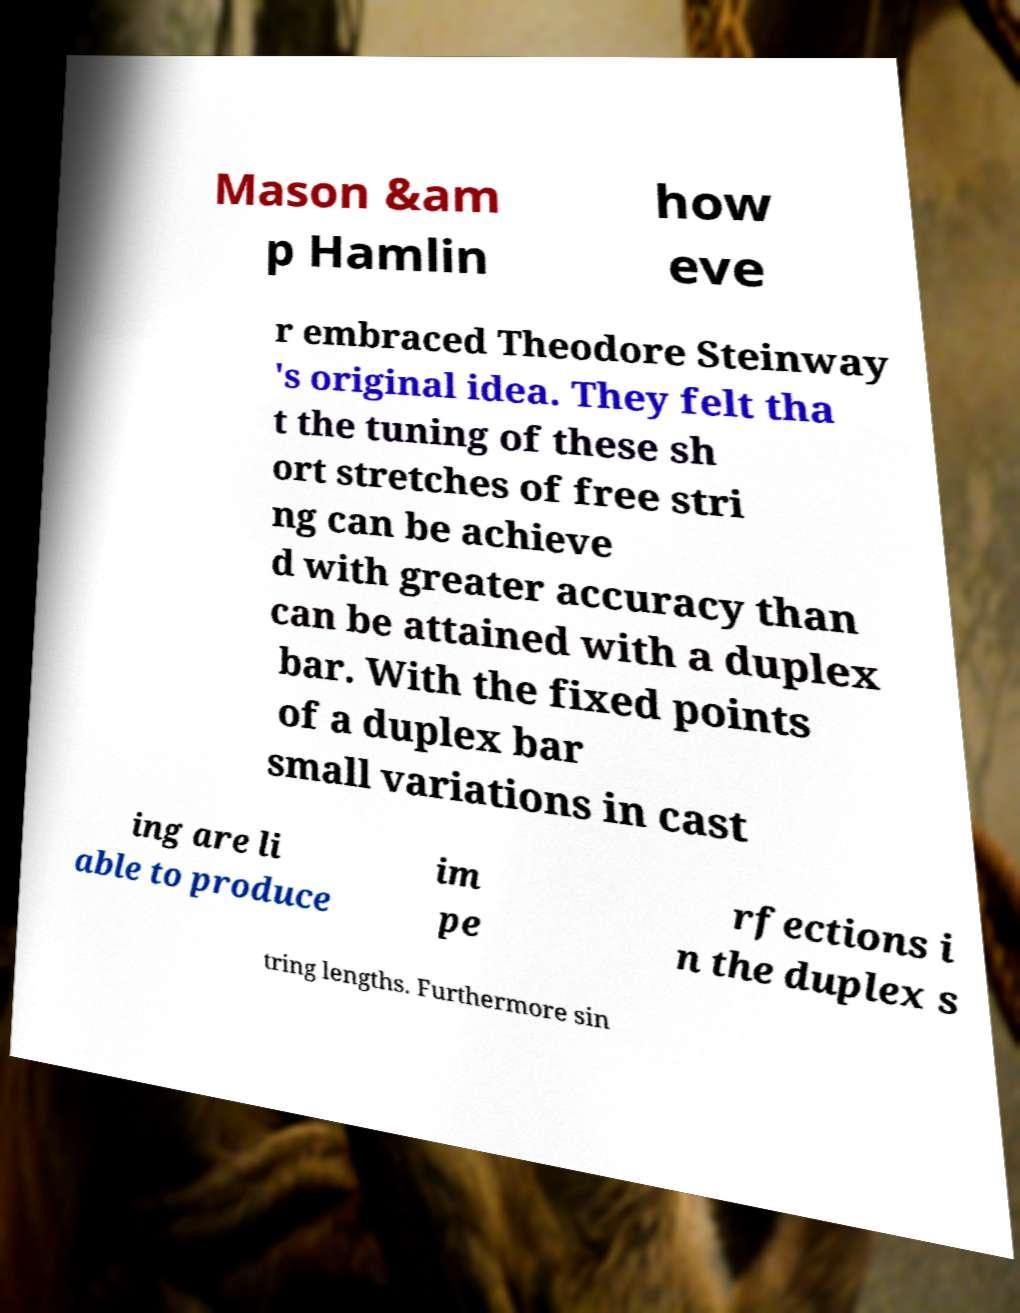Please identify and transcribe the text found in this image. Mason &am p Hamlin how eve r embraced Theodore Steinway 's original idea. They felt tha t the tuning of these sh ort stretches of free stri ng can be achieve d with greater accuracy than can be attained with a duplex bar. With the fixed points of a duplex bar small variations in cast ing are li able to produce im pe rfections i n the duplex s tring lengths. Furthermore sin 